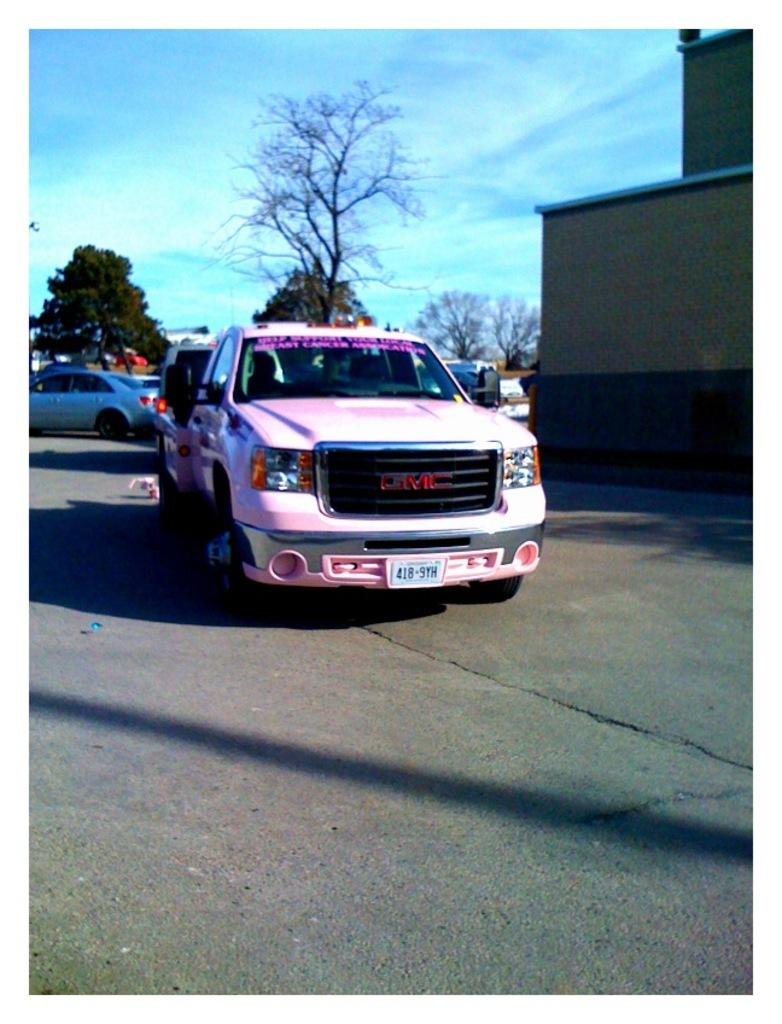What is happening on the road in the image? There are vehicles on the road in the image. What can be seen in the distance behind the vehicles? There are trees and a building visible in the background of the image. What type of stem cells are being taught at the hospital in the image? There is no hospital or teaching activity present in the image. 